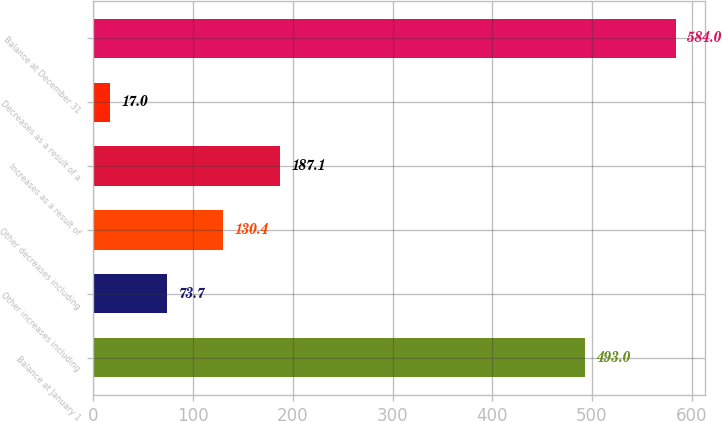Convert chart. <chart><loc_0><loc_0><loc_500><loc_500><bar_chart><fcel>Balance at January 1<fcel>Other increases including<fcel>Other decreases including<fcel>Increases as a result of<fcel>Decreases as a result of a<fcel>Balance at December 31<nl><fcel>493<fcel>73.7<fcel>130.4<fcel>187.1<fcel>17<fcel>584<nl></chart> 